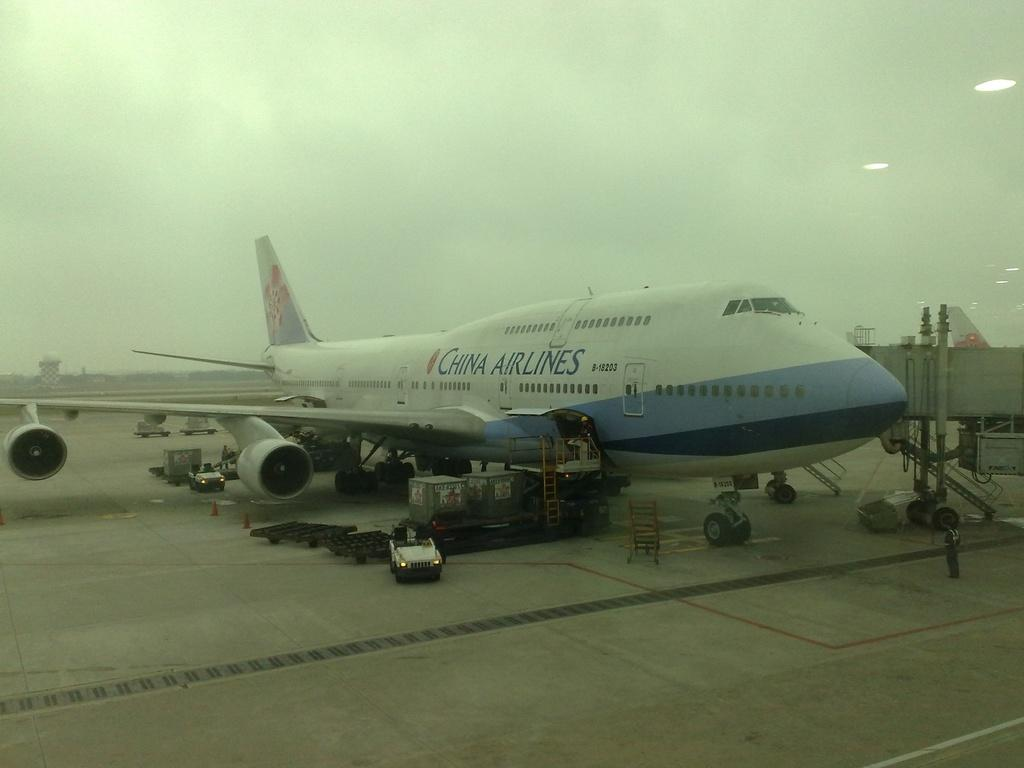Provide a one-sentence caption for the provided image. The China Airlines aircraft has landed at the airport before the storm. 